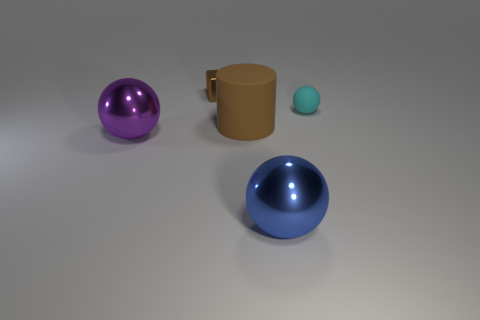The big thing that is the same color as the small metal cube is what shape?
Provide a succinct answer. Cylinder. There is a brown thing that is the same material as the small cyan object; what shape is it?
Your response must be concise. Cylinder. How big is the metallic sphere on the left side of the tiny thing on the left side of the small cyan matte thing?
Offer a very short reply. Large. How many objects are either tiny objects in front of the tiny brown block or metallic objects in front of the rubber sphere?
Provide a succinct answer. 3. Is the number of blue spheres less than the number of big gray cubes?
Provide a short and direct response. No. How many things are either big brown spheres or tiny brown cubes?
Provide a short and direct response. 1. Is the shape of the tiny brown object the same as the purple shiny thing?
Your response must be concise. No. Are there any other things that are the same material as the large blue object?
Give a very brief answer. Yes. Do the ball that is to the right of the big blue metallic sphere and the metallic ball on the left side of the large brown cylinder have the same size?
Offer a very short reply. No. What material is the sphere that is both to the right of the big brown rubber cylinder and in front of the rubber sphere?
Your answer should be very brief. Metal. 